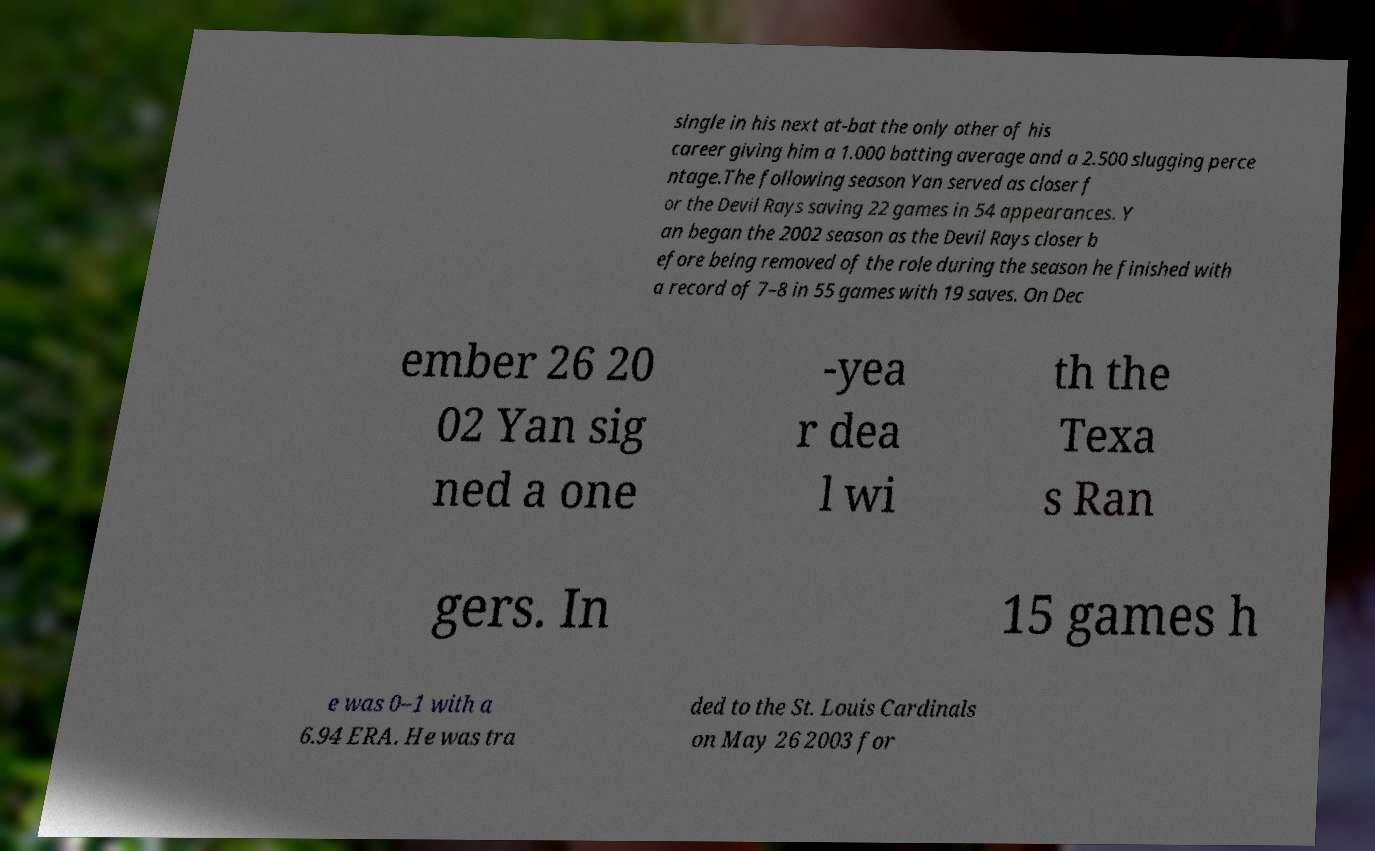For documentation purposes, I need the text within this image transcribed. Could you provide that? single in his next at-bat the only other of his career giving him a 1.000 batting average and a 2.500 slugging perce ntage.The following season Yan served as closer f or the Devil Rays saving 22 games in 54 appearances. Y an began the 2002 season as the Devil Rays closer b efore being removed of the role during the season he finished with a record of 7–8 in 55 games with 19 saves. On Dec ember 26 20 02 Yan sig ned a one -yea r dea l wi th the Texa s Ran gers. In 15 games h e was 0–1 with a 6.94 ERA. He was tra ded to the St. Louis Cardinals on May 26 2003 for 